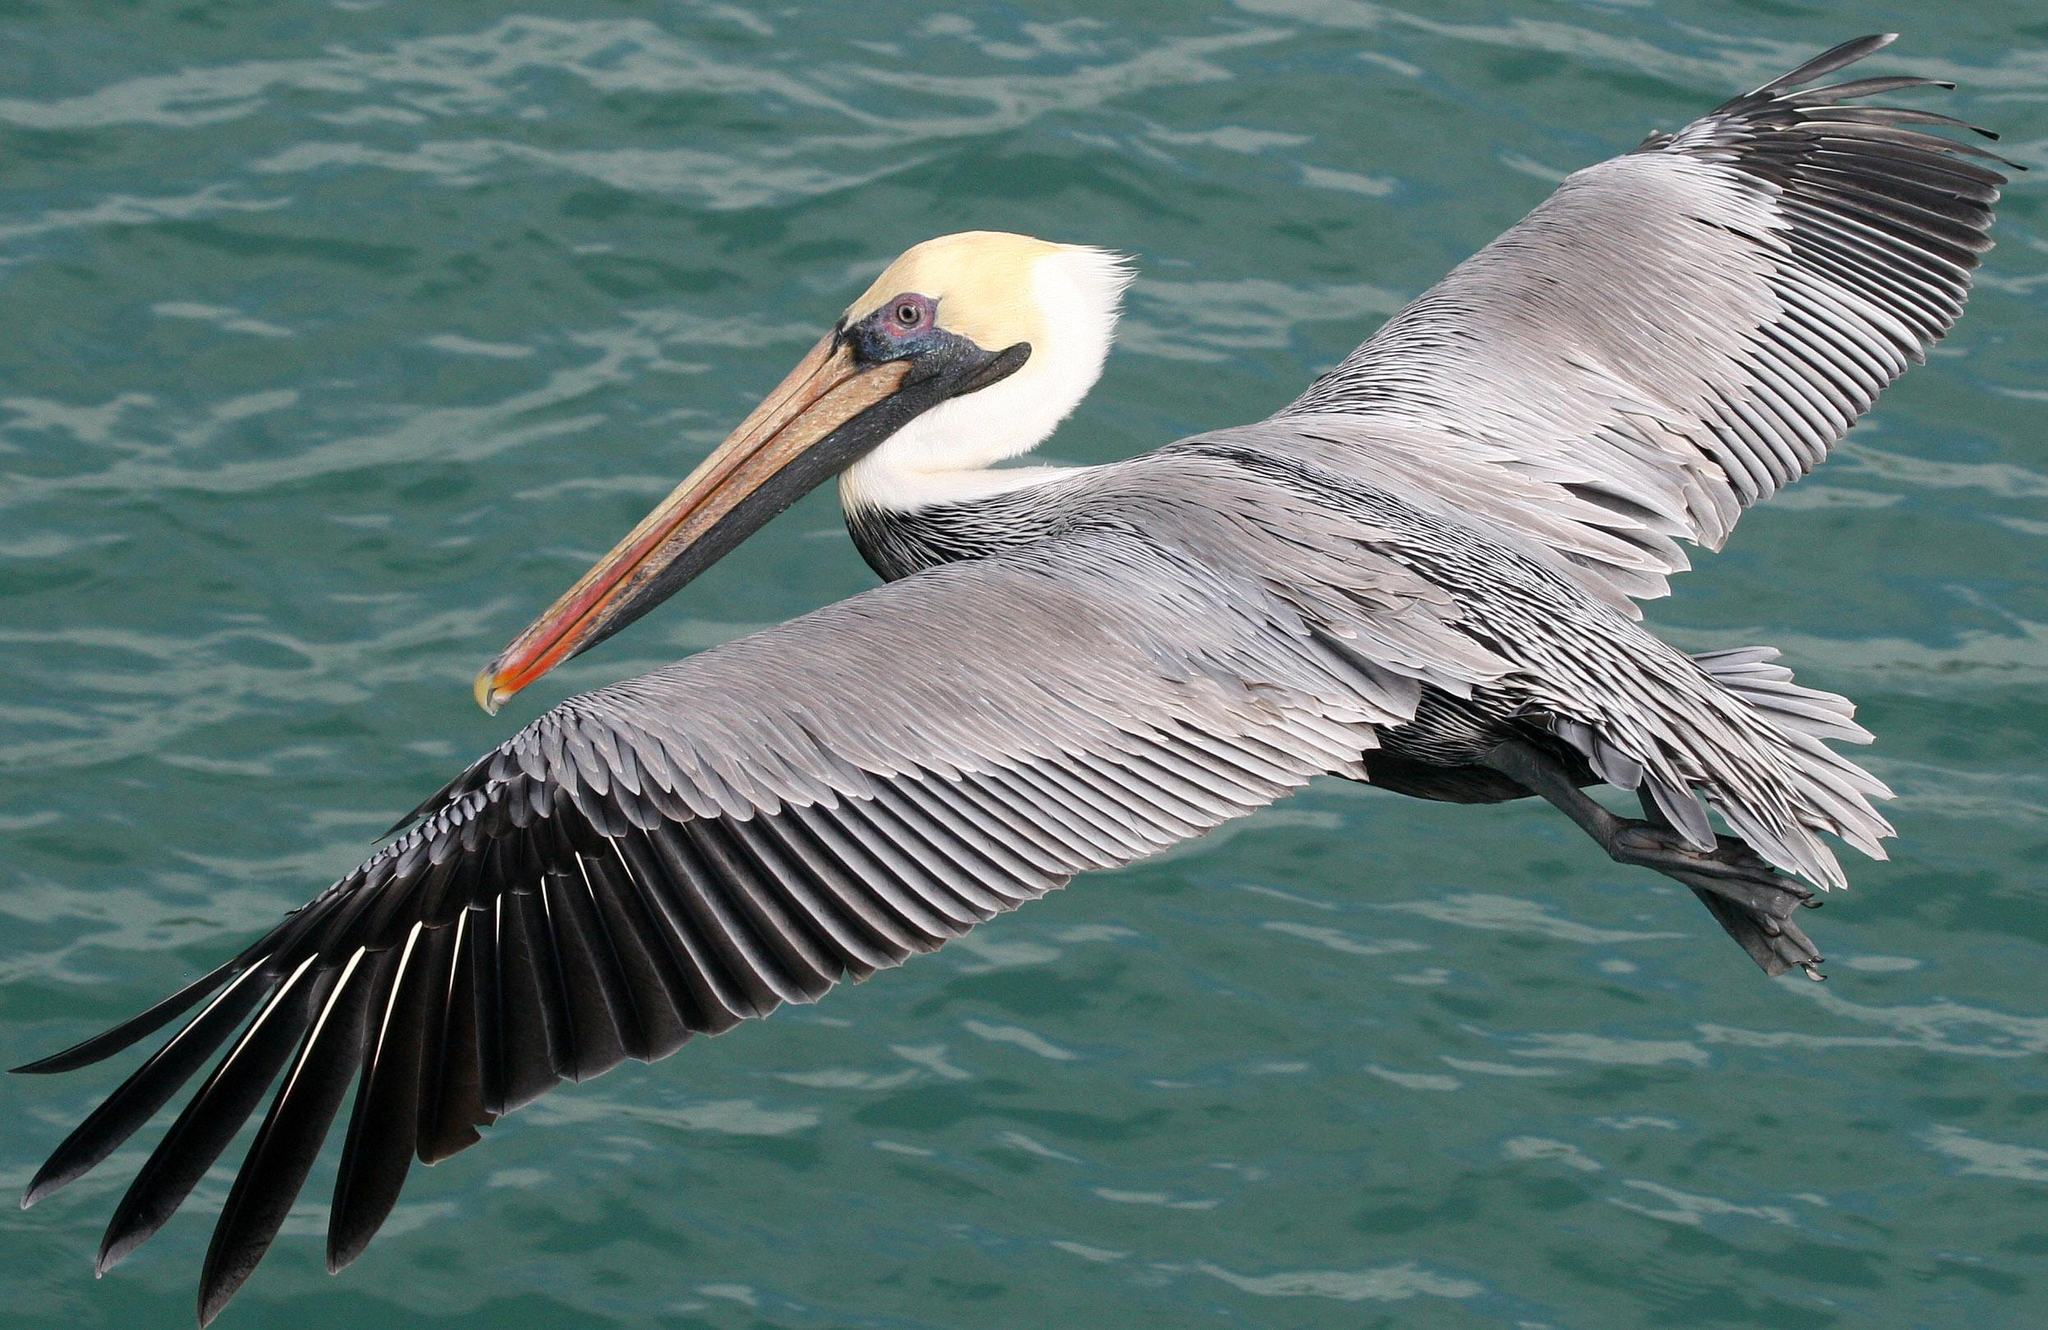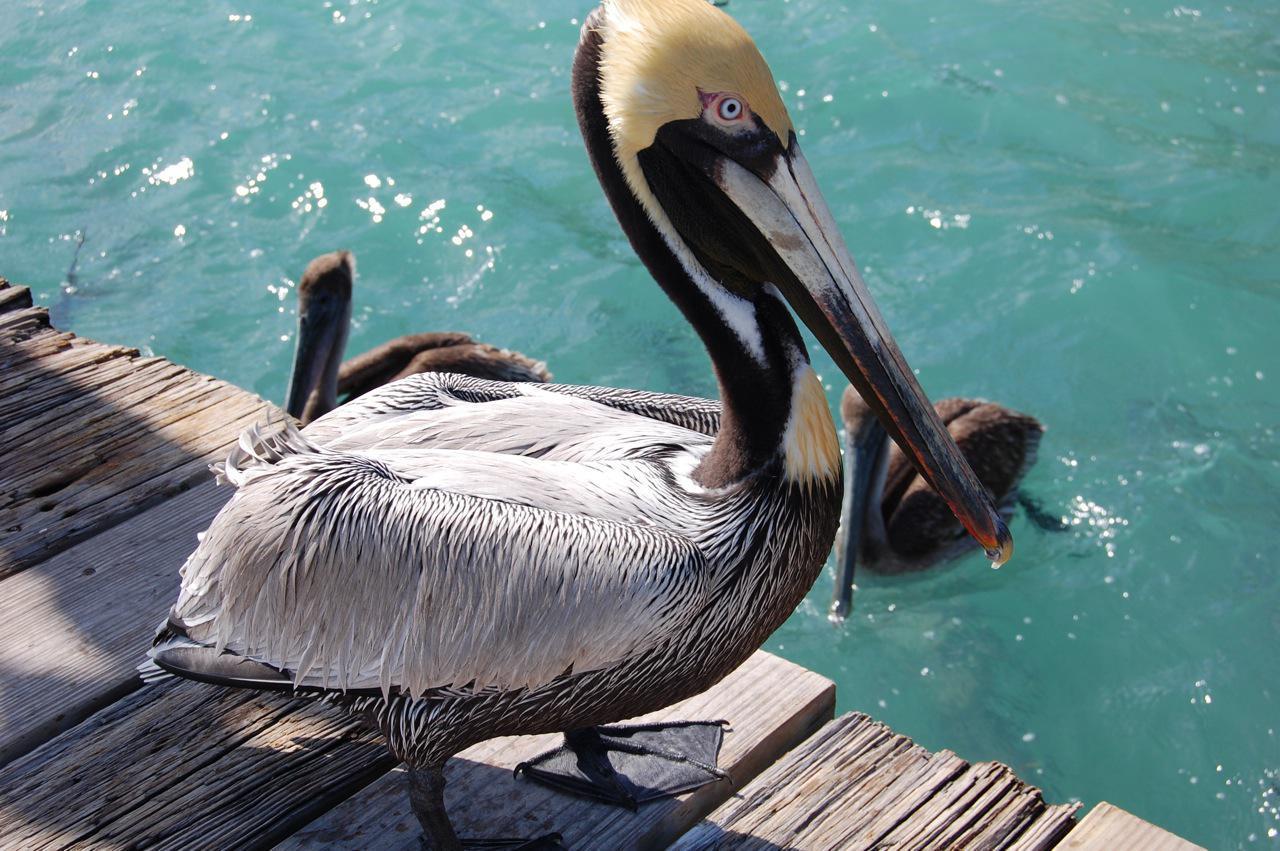The first image is the image on the left, the second image is the image on the right. Examine the images to the left and right. Is the description "The left image features one pelican standing on a smooth rock, and the right image features one pelican swimming on water." accurate? Answer yes or no. No. The first image is the image on the left, the second image is the image on the right. Given the left and right images, does the statement "In both images a pelican's throat pouch is fully visible." hold true? Answer yes or no. No. 